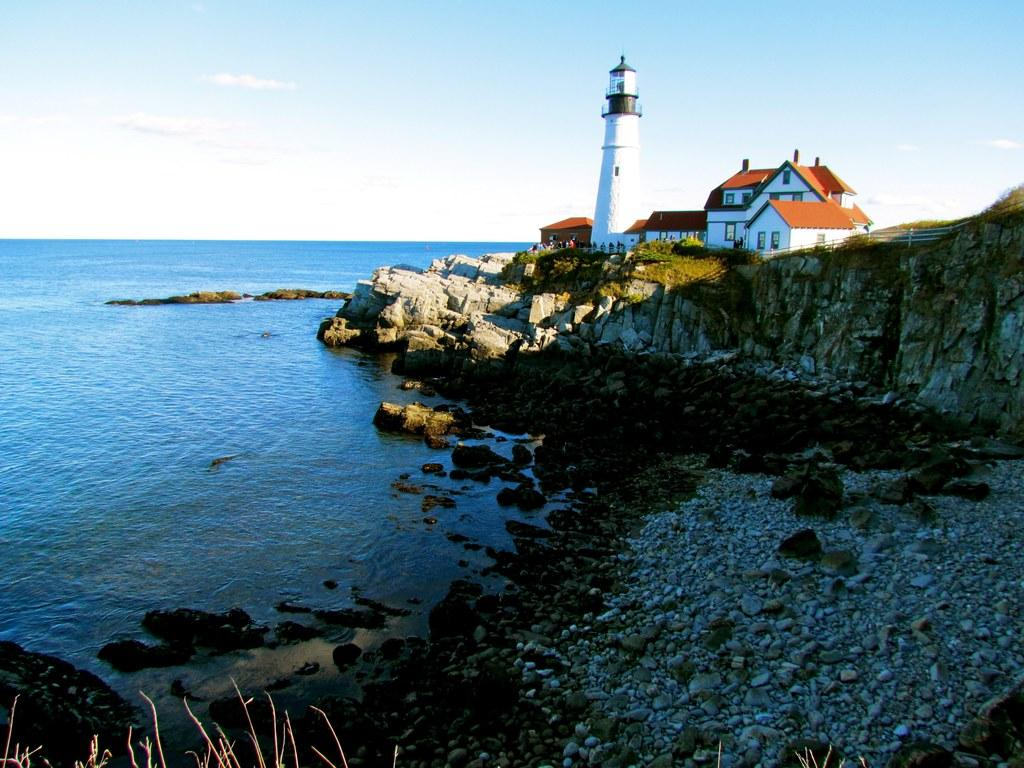What is the main structure in the image? There is a lighthouse in the image. What other buildings can be seen in the image? There are houses in the image. What natural element is visible in the image? There is water visible in the image. What type of terrain is present in the image? There are stones in the image. How would you describe the weather in the image? The sky is blue and cloudy in the image. What type of pleasure can be seen enjoying the water in the image? There is no indication of any pleasure or person enjoying the water in the image. 